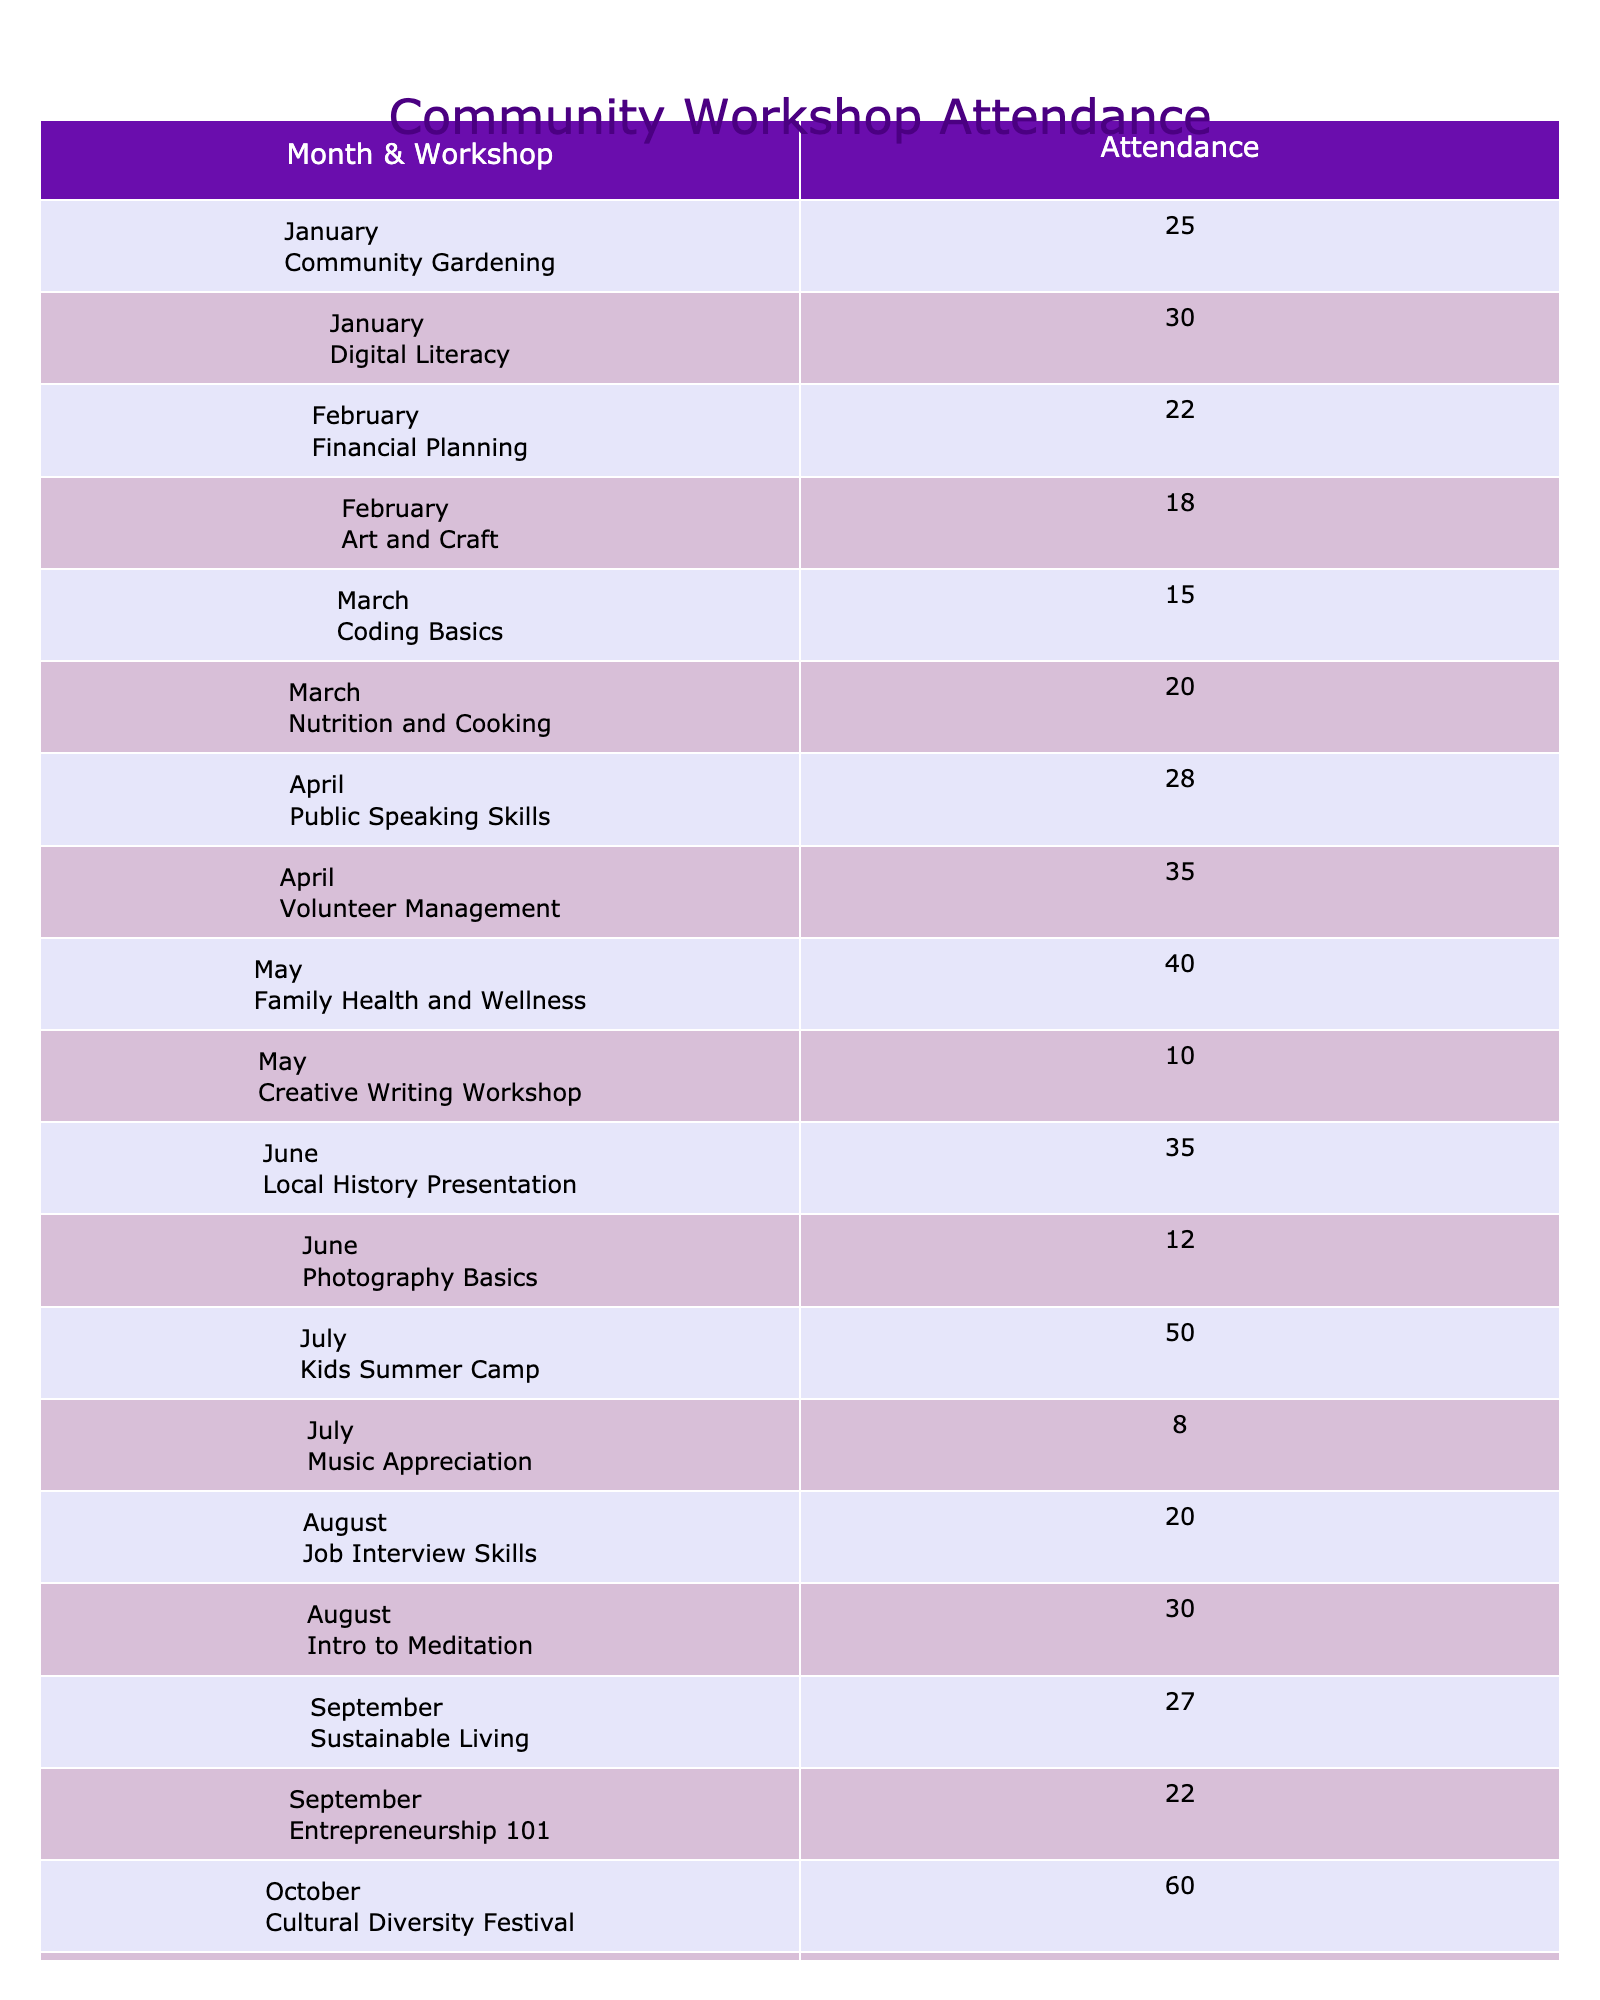What is the highest attendance for a workshop in the year? The table shows various workshops with their attendance figures. Scanning through the Attendance column, the highest number is 60, which corresponds to the Cultural Diversity Festival in October.
Answer: 60 Which month had the lowest average attendance across its workshops? To determine the lowest average attendance, I will first find the attendance figures for each month: January (55), February (40), March (35), April (63), May (50), June (47), July (58), August (50), September (49), October (75), November (43), December (75). The lowest average is for February (40).
Answer: February Is there a workshop with an attendance count of exactly 50? Looking at the table, the Kids Summer Camp in July has an attendance of 50, confirming that it exists.
Answer: Yes What is the total attendance for all workshops in November? From the table, the attendance figures for November are 24 (Public Policy Discussion) and 19 (Environmental Awareness). Summing them gives 24 + 19 = 43, illustrating the total attendance for that month.
Answer: 43 How many workshops had an attendance figure greater than 30? By checking each attendance figure, I find that the workshops with an attendance greater than 30 are: Digital Literacy (30), Volunteer Management (35), Family Health and Wellness (40), Local History Presentation (35), Kids Summer Camp (50), Intro to Meditation (30), October workshops (60 and 15), and Year-End Celebration (45). Counting these gives a total of 8 workshops.
Answer: 8 Which workshop had the lowest attendance and in what month? The workshop with the lowest attendance is the Creative Writing Workshop in May, which had only 10 attendees. This can be verified by checking the attendance figures.
Answer: Creative Writing Workshop in May What is the average attendance for all workshops in the year? To calculate the average, I first sum all attendance figures: 25 + 30 + 22 + 18 + 15 + 20 + 28 + 35 + 40 + 10 + 35 + 12 + 50 + 8 + 20 + 30 + 27 + 22 + 60 + 15 + 24 + 19 + 45 + 30 =  480. Since there are 24 workshops, I divide the sum by 24 which gives an average of 20. The average attendance is 480/24 = 20.
Answer: 20 How many workshops were conducted in the month of July? The table shows two workshops in July: Kids Summer Camp and Music Appreciation. Therefore, there were 2 workshops in this month.
Answer: 2 Did more than 5 workshops have an attendance of 30 or less? Counting the workshops with attendance of 30 or less from the table: Financial Planning (22), Art and Craft (18), Coding Basics (15), Creative Writing Workshop (10), Photography Basics (12), Music Appreciation (8), and Entrepreneurship 101 (22) gives a total of 7 workshops. Therefore, the statement is true.
Answer: Yes 